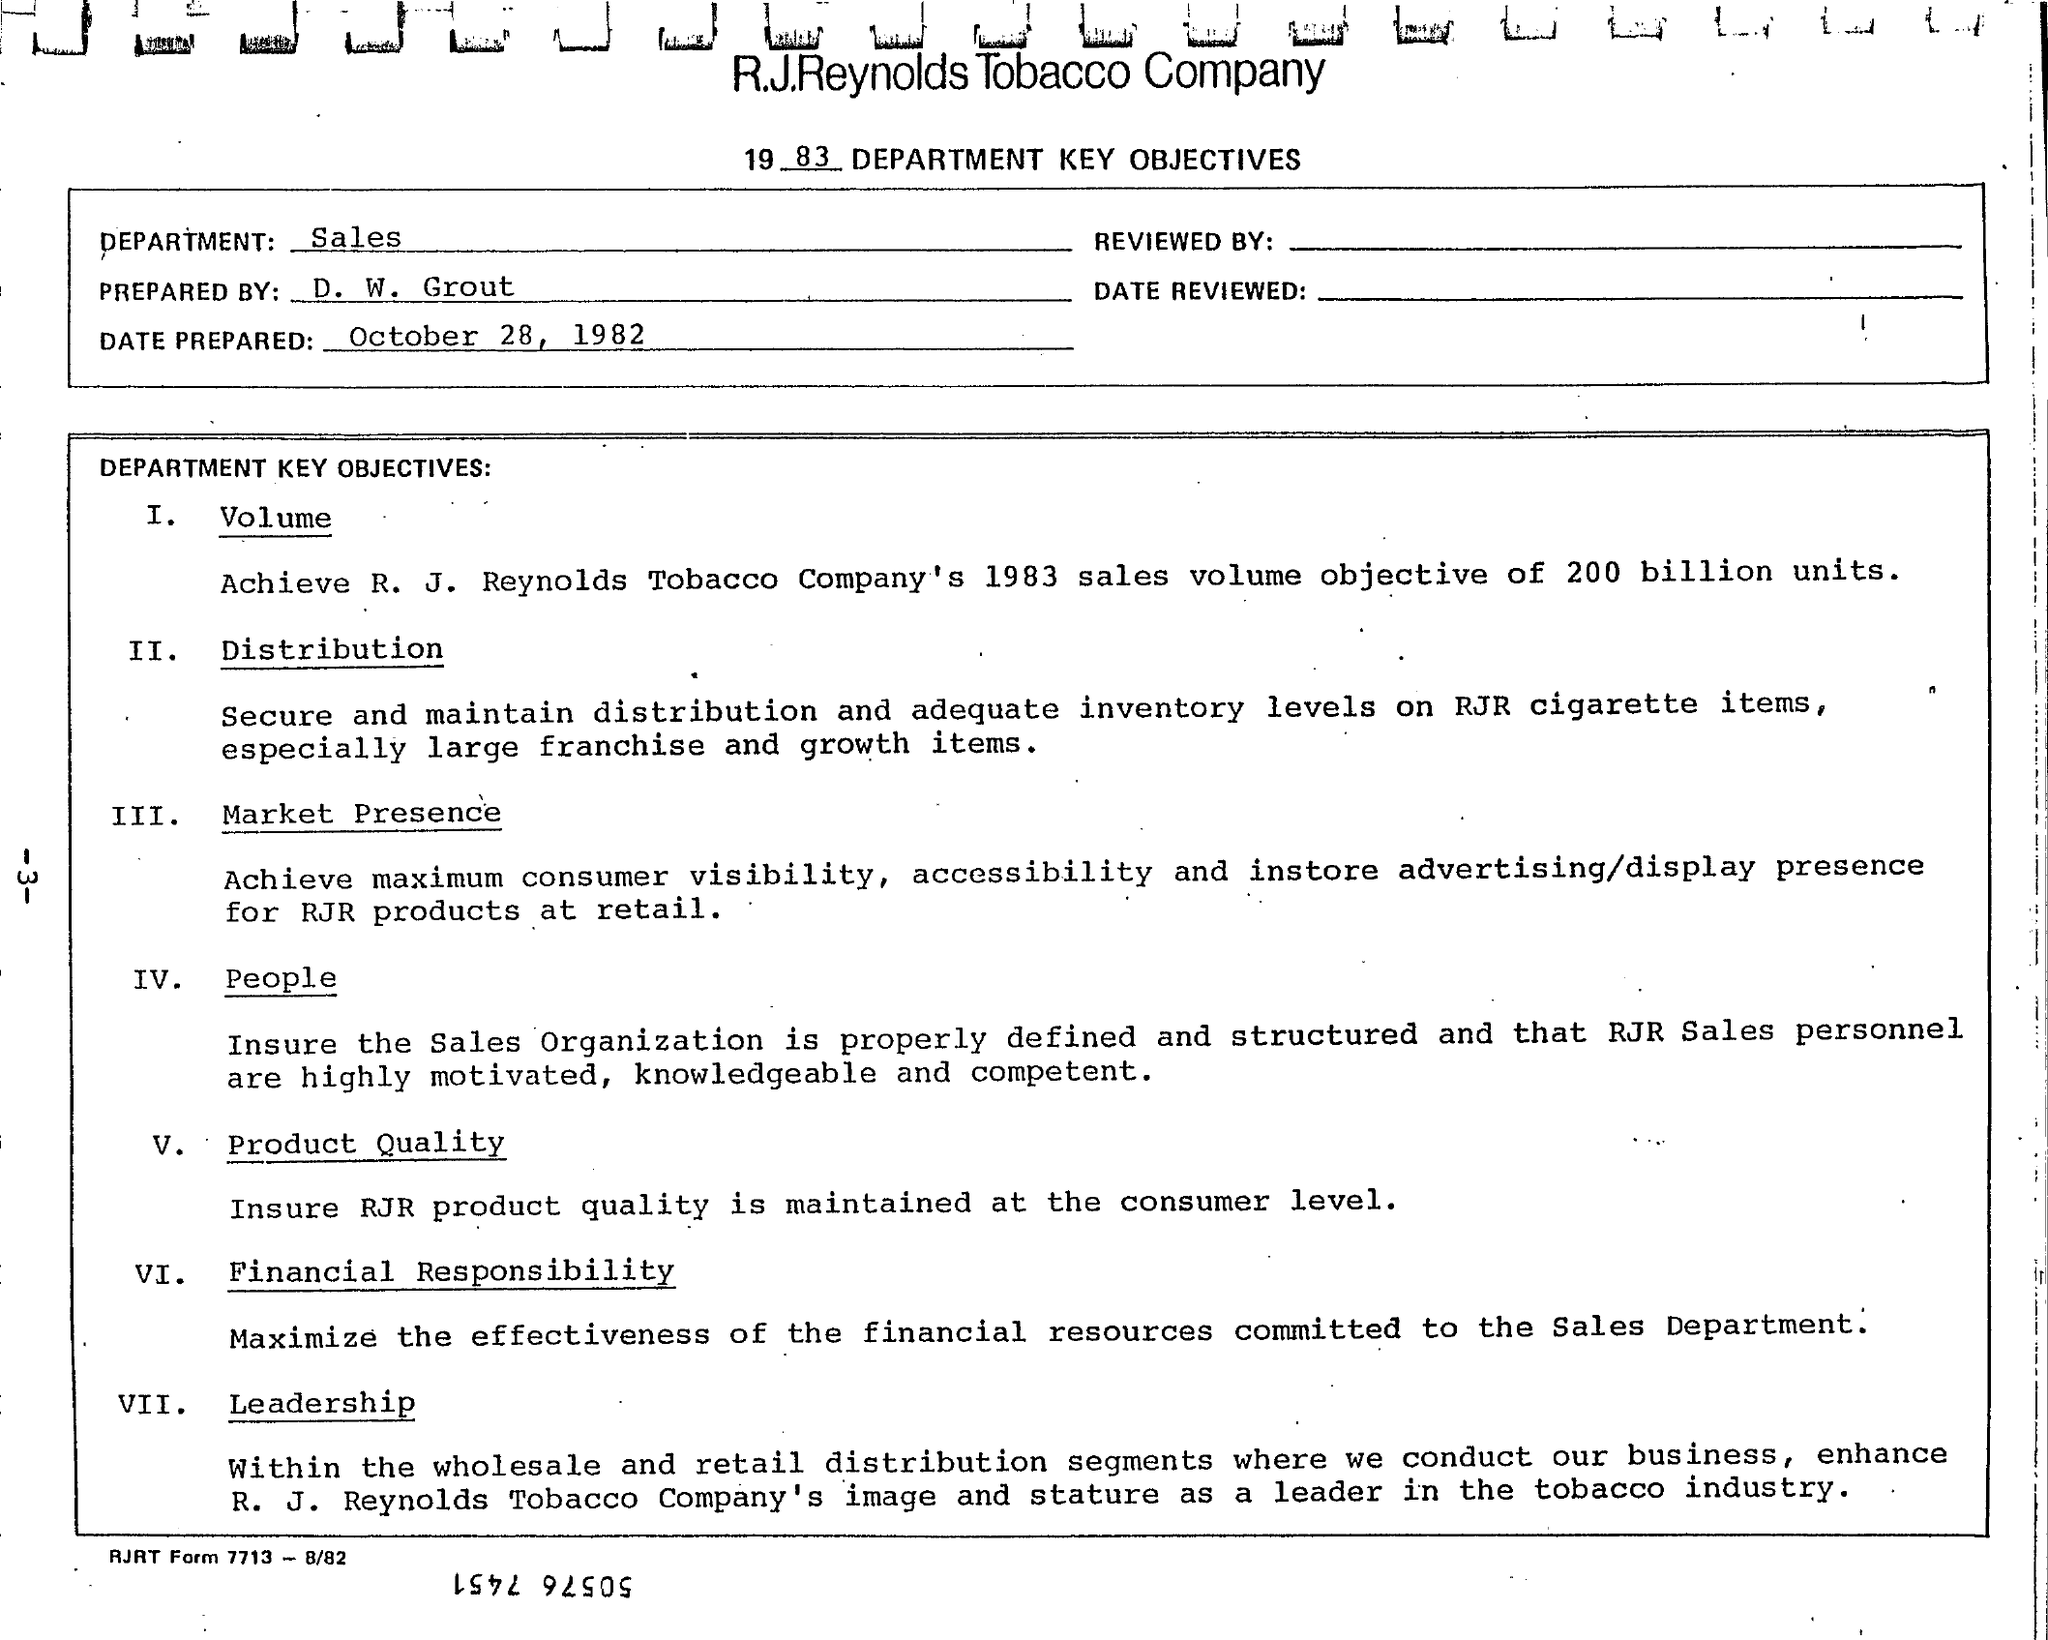Identify some key points in this picture. The Sales Department is the correct answer. The title of the document is '1983 department key objectives'. The document was prepared by D. W. Grout. 